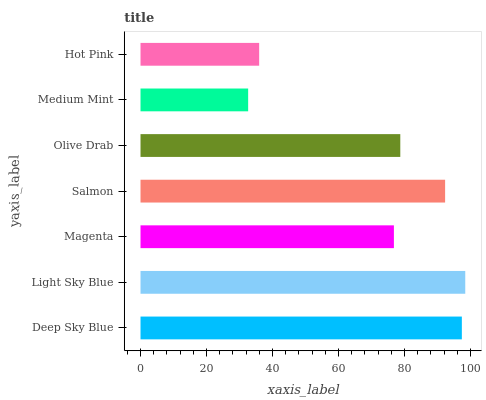Is Medium Mint the minimum?
Answer yes or no. Yes. Is Light Sky Blue the maximum?
Answer yes or no. Yes. Is Magenta the minimum?
Answer yes or no. No. Is Magenta the maximum?
Answer yes or no. No. Is Light Sky Blue greater than Magenta?
Answer yes or no. Yes. Is Magenta less than Light Sky Blue?
Answer yes or no. Yes. Is Magenta greater than Light Sky Blue?
Answer yes or no. No. Is Light Sky Blue less than Magenta?
Answer yes or no. No. Is Olive Drab the high median?
Answer yes or no. Yes. Is Olive Drab the low median?
Answer yes or no. Yes. Is Deep Sky Blue the high median?
Answer yes or no. No. Is Magenta the low median?
Answer yes or no. No. 